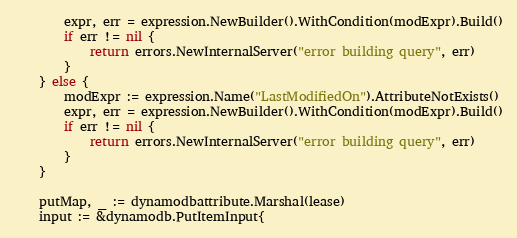Convert code to text. <code><loc_0><loc_0><loc_500><loc_500><_Go_>		expr, err = expression.NewBuilder().WithCondition(modExpr).Build()
		if err != nil {
			return errors.NewInternalServer("error building query", err)
		}
	} else {
		modExpr := expression.Name("LastModifiedOn").AttributeNotExists()
		expr, err = expression.NewBuilder().WithCondition(modExpr).Build()
		if err != nil {
			return errors.NewInternalServer("error building query", err)
		}
	}

	putMap, _ := dynamodbattribute.Marshal(lease)
	input := &dynamodb.PutItemInput{</code> 